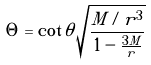Convert formula to latex. <formula><loc_0><loc_0><loc_500><loc_500>\Theta = \cot \theta \sqrt { \frac { M / r ^ { 3 } } { 1 - \frac { 3 M } { r } } }</formula> 